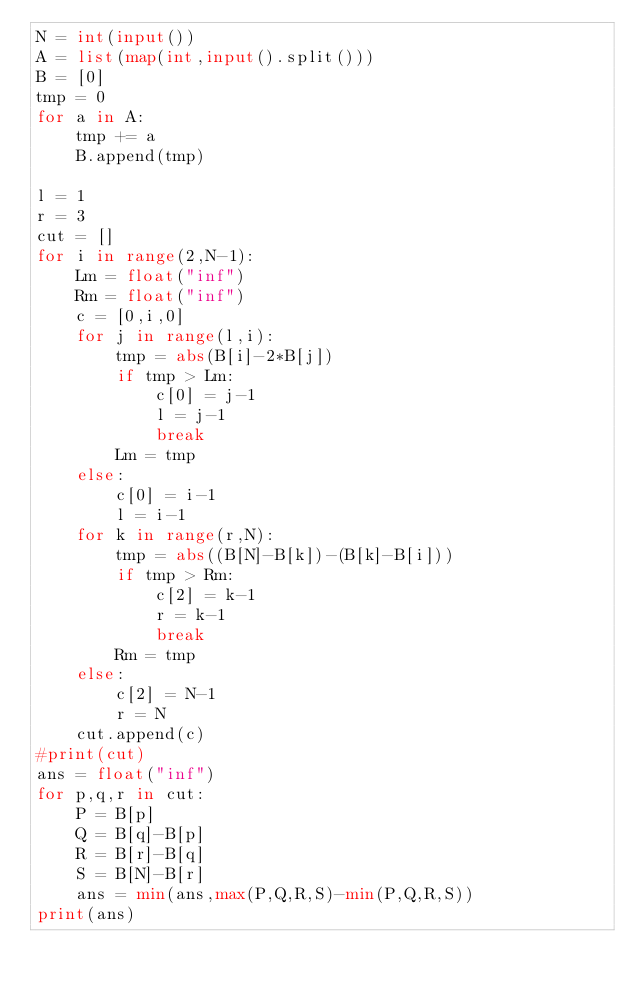Convert code to text. <code><loc_0><loc_0><loc_500><loc_500><_Python_>N = int(input())
A = list(map(int,input().split()))
B = [0]
tmp = 0
for a in A:
    tmp += a
    B.append(tmp)

l = 1
r = 3
cut = []
for i in range(2,N-1):
    Lm = float("inf")
    Rm = float("inf")
    c = [0,i,0]
    for j in range(l,i):
        tmp = abs(B[i]-2*B[j])
        if tmp > Lm:
            c[0] = j-1
            l = j-1
            break
        Lm = tmp
    else:
        c[0] = i-1
        l = i-1
    for k in range(r,N):
        tmp = abs((B[N]-B[k])-(B[k]-B[i]))
        if tmp > Rm:
            c[2] = k-1
            r = k-1
            break
        Rm = tmp
    else:
        c[2] = N-1
        r = N
    cut.append(c)
#print(cut)
ans = float("inf")
for p,q,r in cut:
    P = B[p]
    Q = B[q]-B[p]
    R = B[r]-B[q]
    S = B[N]-B[r]
    ans = min(ans,max(P,Q,R,S)-min(P,Q,R,S))
print(ans)
</code> 